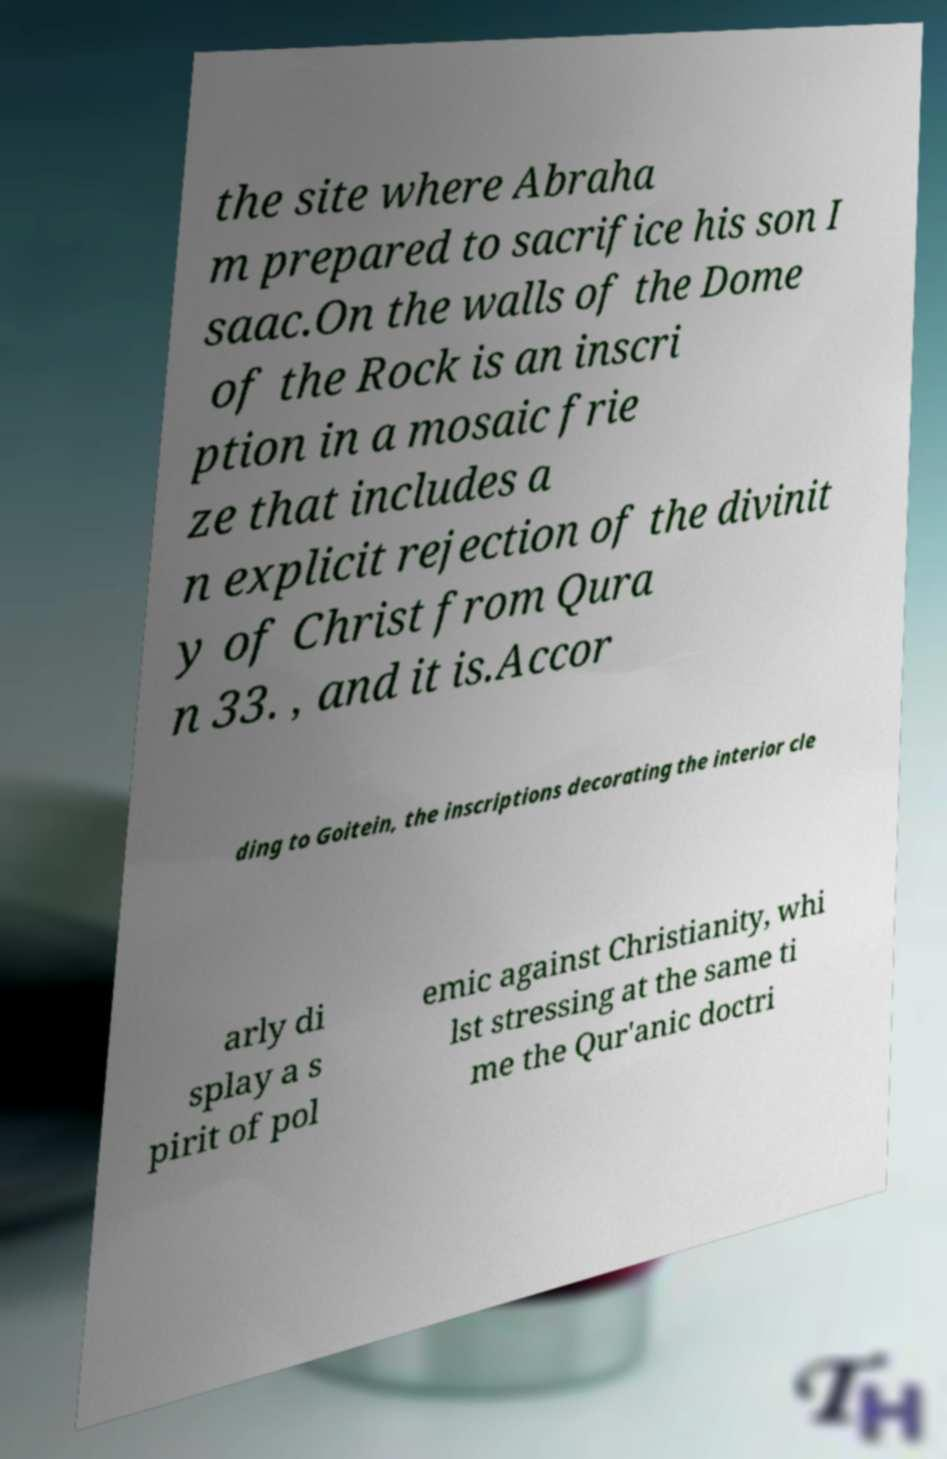I need the written content from this picture converted into text. Can you do that? the site where Abraha m prepared to sacrifice his son I saac.On the walls of the Dome of the Rock is an inscri ption in a mosaic frie ze that includes a n explicit rejection of the divinit y of Christ from Qura n 33. , and it is.Accor ding to Goitein, the inscriptions decorating the interior cle arly di splay a s pirit of pol emic against Christianity, whi lst stressing at the same ti me the Qur'anic doctri 